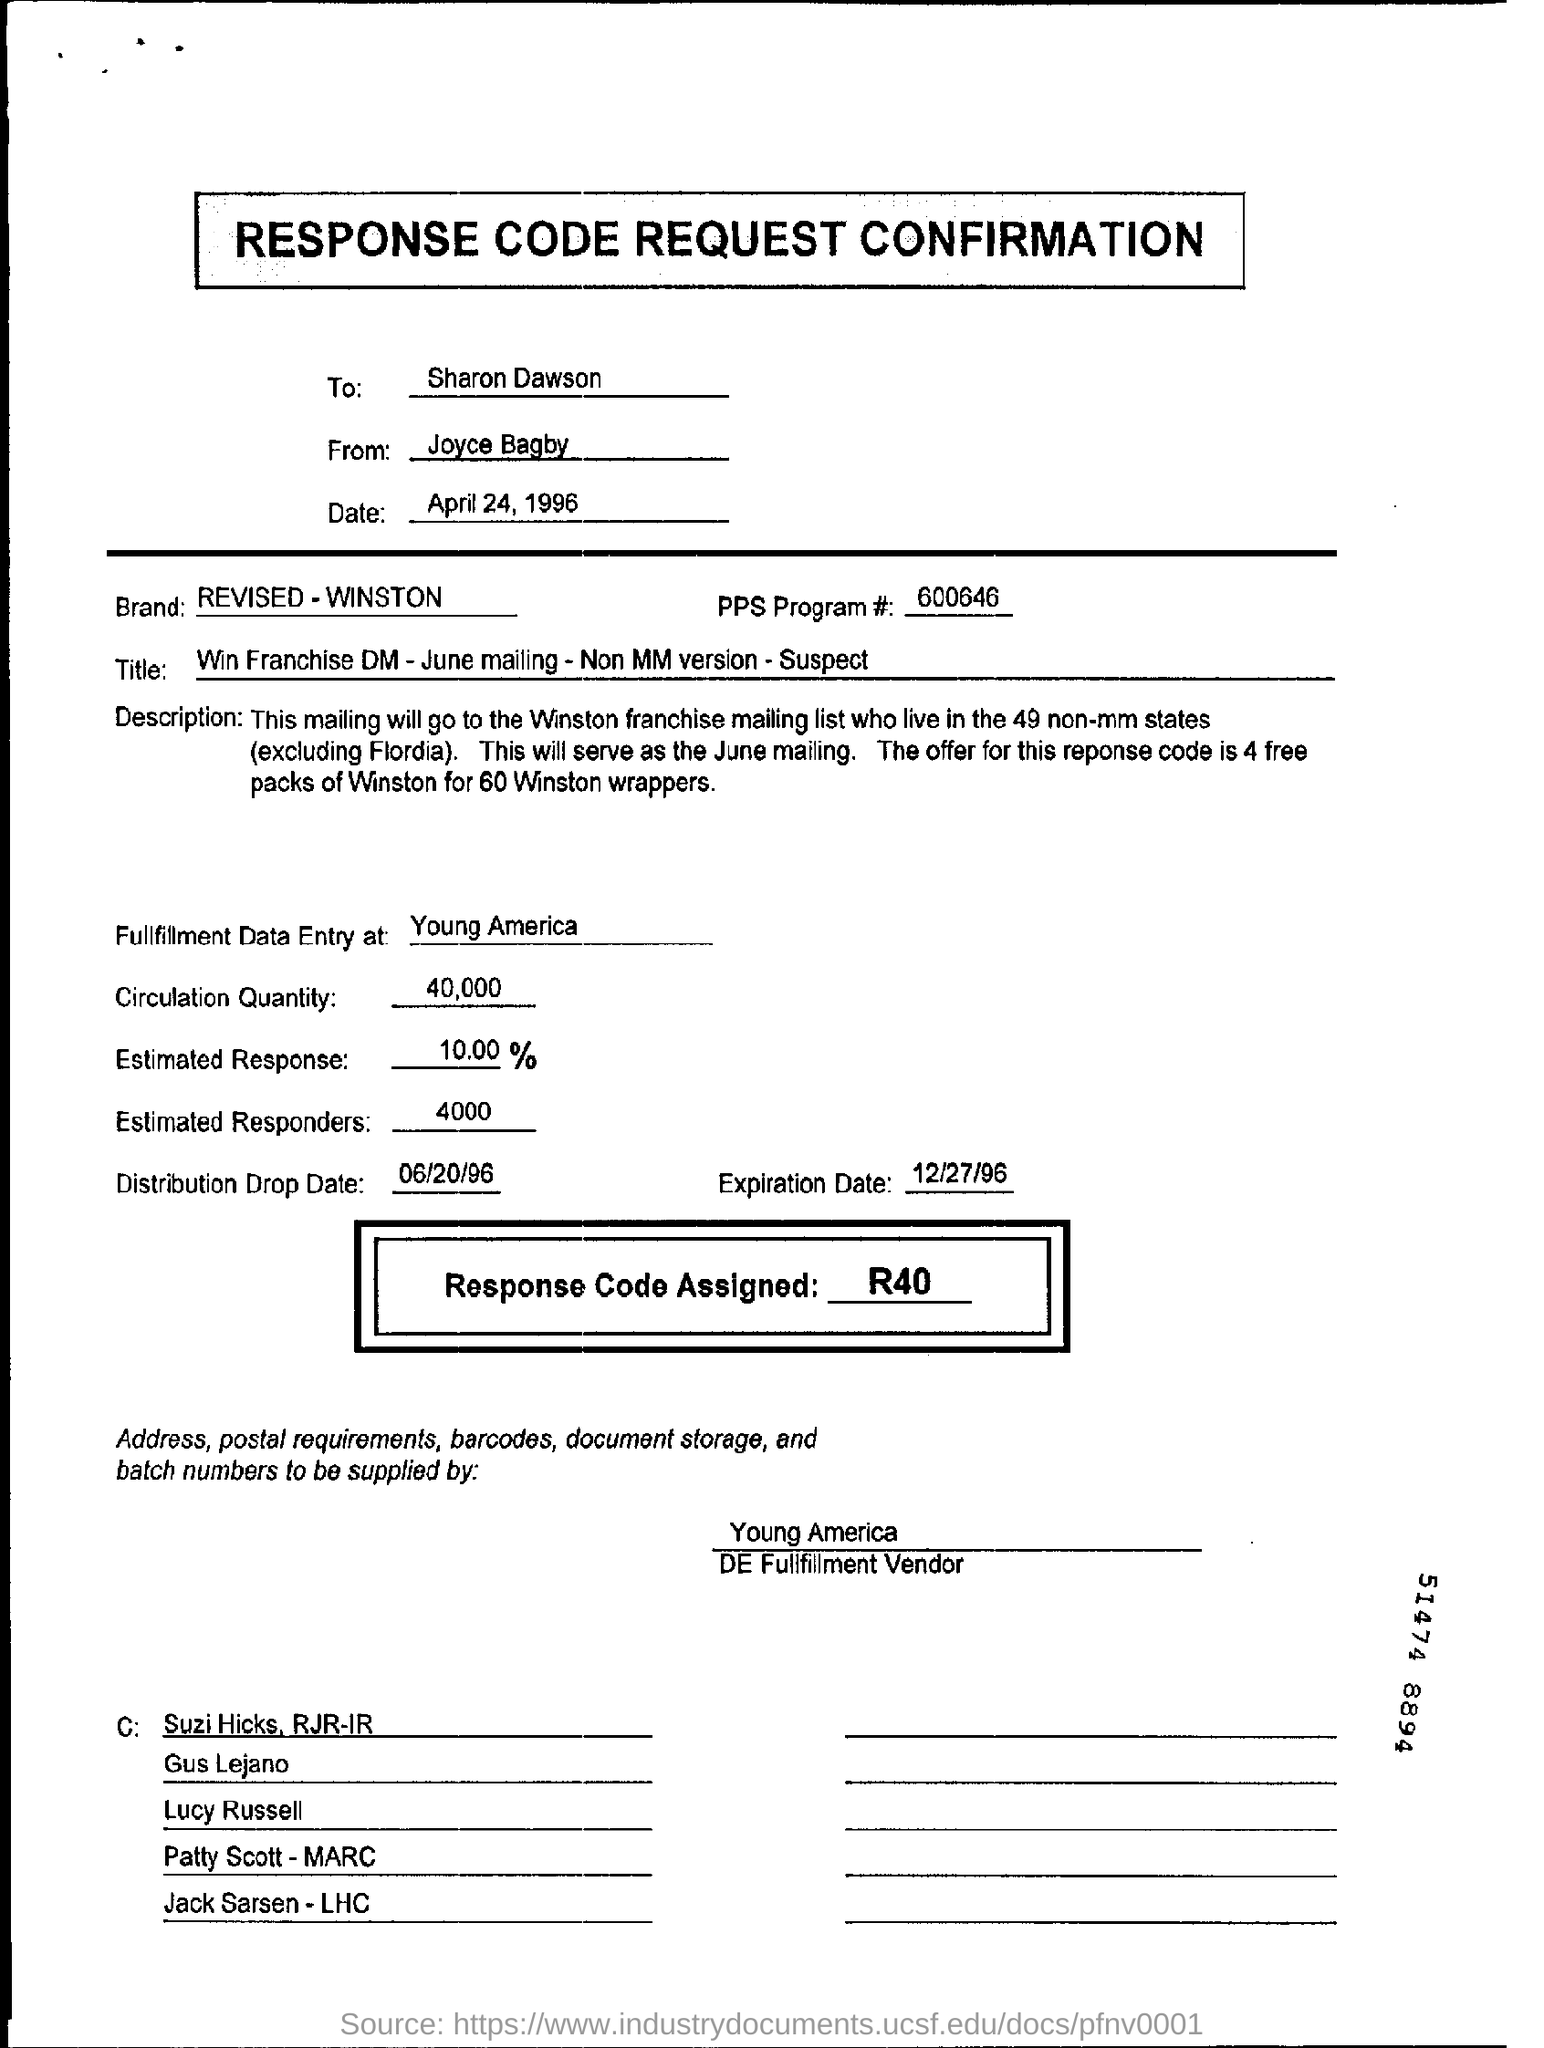Point out several critical features in this image. The brand for the response code request confirmation is REVISED - WINSTON. On April 24, 1996, the response code request confirmation was sent. The distribution drop date is June 20, 1996. The fulfilment data entry is done in Young America. The circulation quantity is 40,000. 